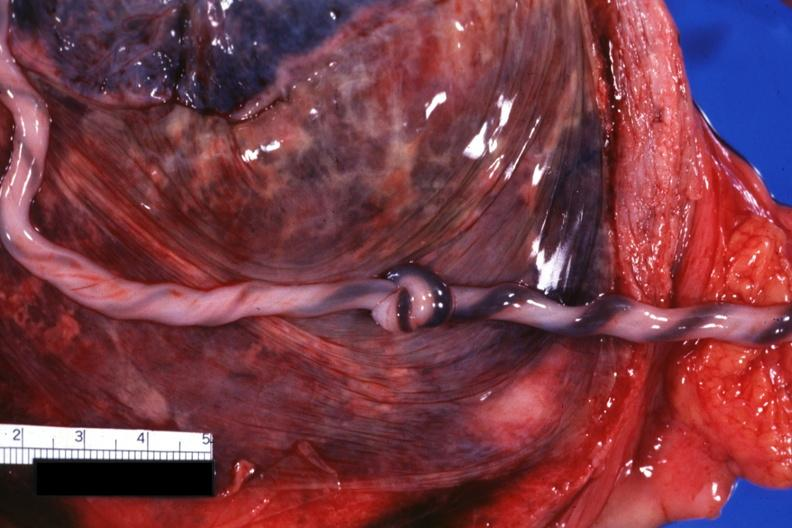does this image show well shown knot?
Answer the question using a single word or phrase. Yes 